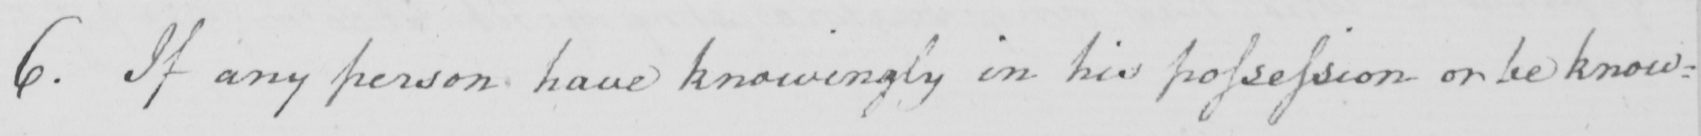Can you read and transcribe this handwriting? 6 . If any person have knowingly in his possession or be know= 